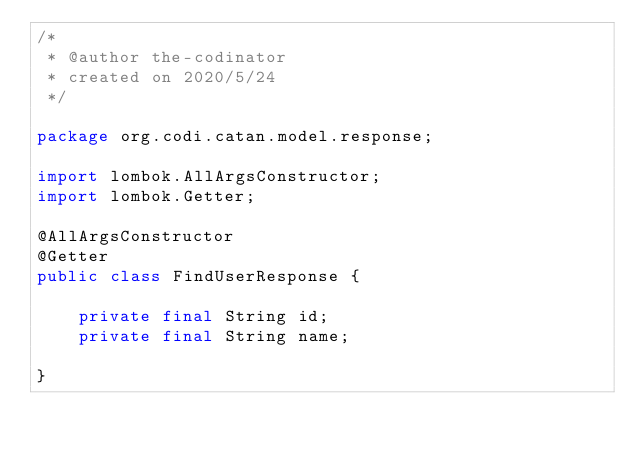Convert code to text. <code><loc_0><loc_0><loc_500><loc_500><_Java_>/*
 * @author the-codinator
 * created on 2020/5/24
 */

package org.codi.catan.model.response;

import lombok.AllArgsConstructor;
import lombok.Getter;

@AllArgsConstructor
@Getter
public class FindUserResponse {

    private final String id;
    private final String name;

}
</code> 